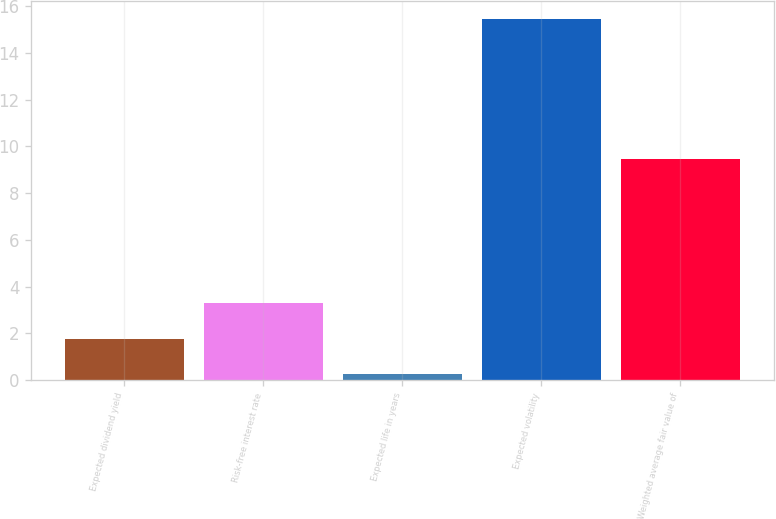Convert chart to OTSL. <chart><loc_0><loc_0><loc_500><loc_500><bar_chart><fcel>Expected dividend yield<fcel>Risk-free interest rate<fcel>Expected life in years<fcel>Expected volatility<fcel>Weighted average fair value of<nl><fcel>1.77<fcel>3.29<fcel>0.25<fcel>15.46<fcel>9.46<nl></chart> 